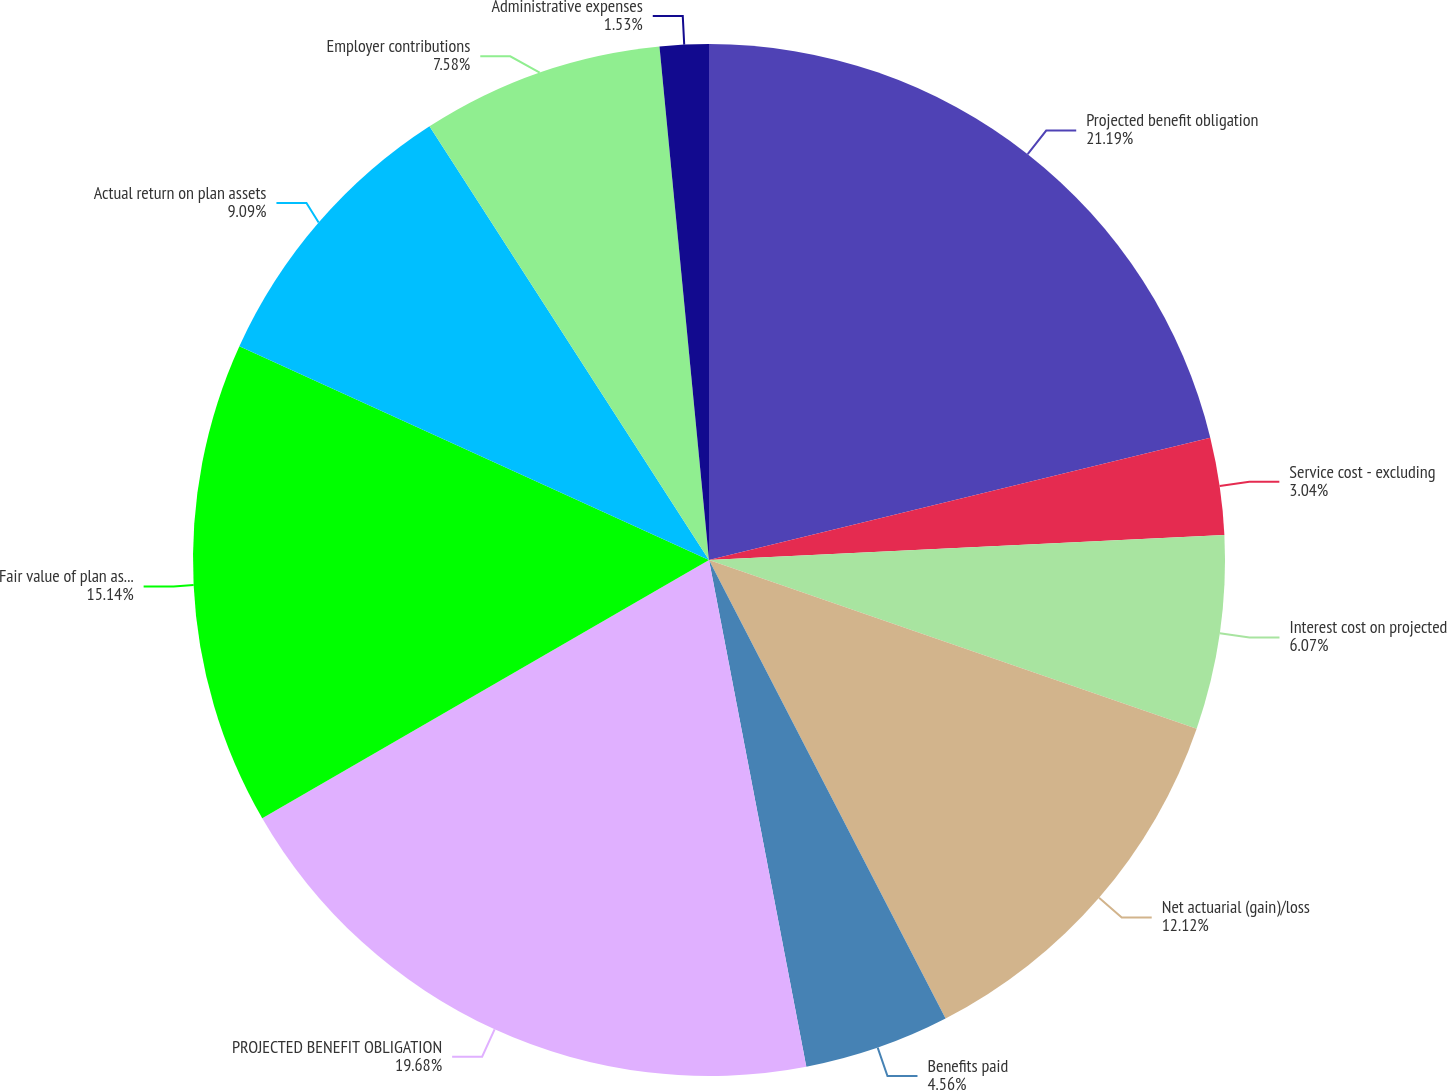<chart> <loc_0><loc_0><loc_500><loc_500><pie_chart><fcel>Projected benefit obligation<fcel>Service cost - excluding<fcel>Interest cost on projected<fcel>Net actuarial (gain)/loss<fcel>Benefits paid<fcel>PROJECTED BENEFIT OBLIGATION<fcel>Fair value of plan assets at<fcel>Actual return on plan assets<fcel>Employer contributions<fcel>Administrative expenses<nl><fcel>21.19%<fcel>3.04%<fcel>6.07%<fcel>12.12%<fcel>4.56%<fcel>19.68%<fcel>15.14%<fcel>9.09%<fcel>7.58%<fcel>1.53%<nl></chart> 